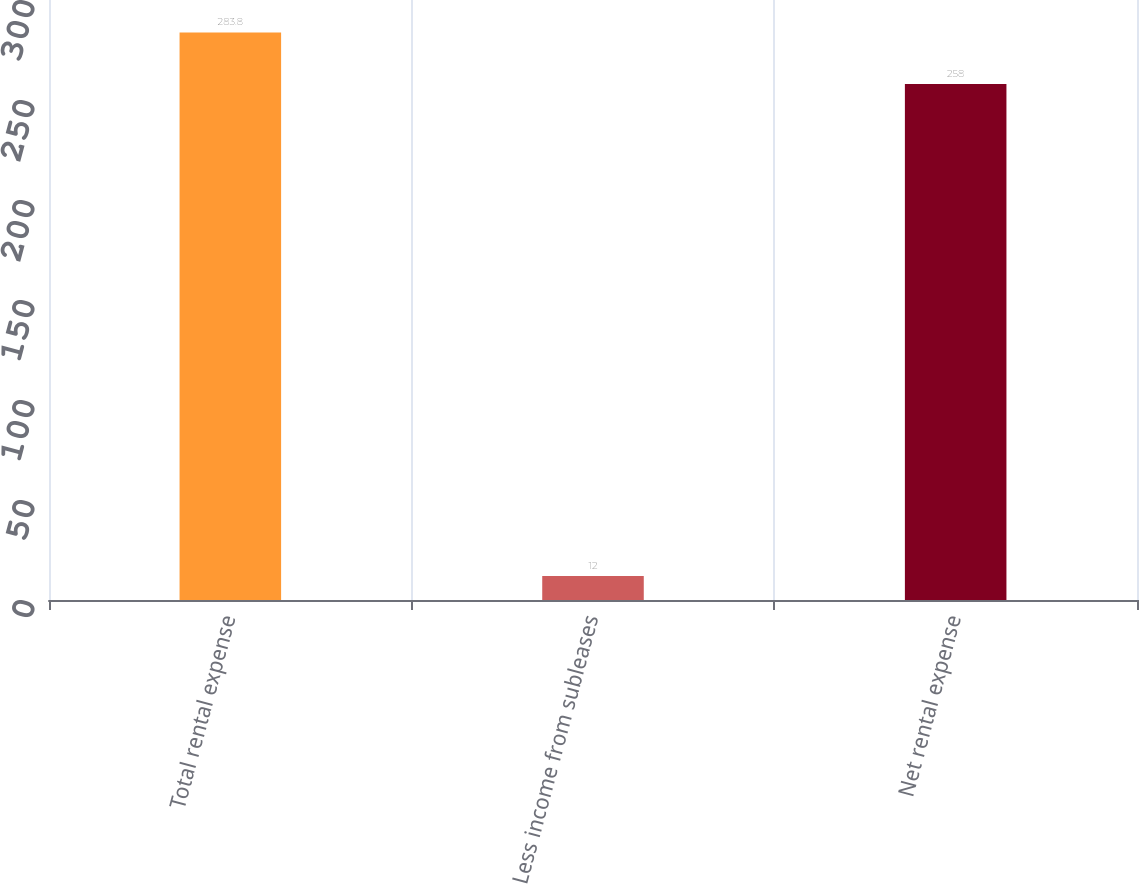<chart> <loc_0><loc_0><loc_500><loc_500><bar_chart><fcel>Total rental expense<fcel>Less income from subleases<fcel>Net rental expense<nl><fcel>283.8<fcel>12<fcel>258<nl></chart> 